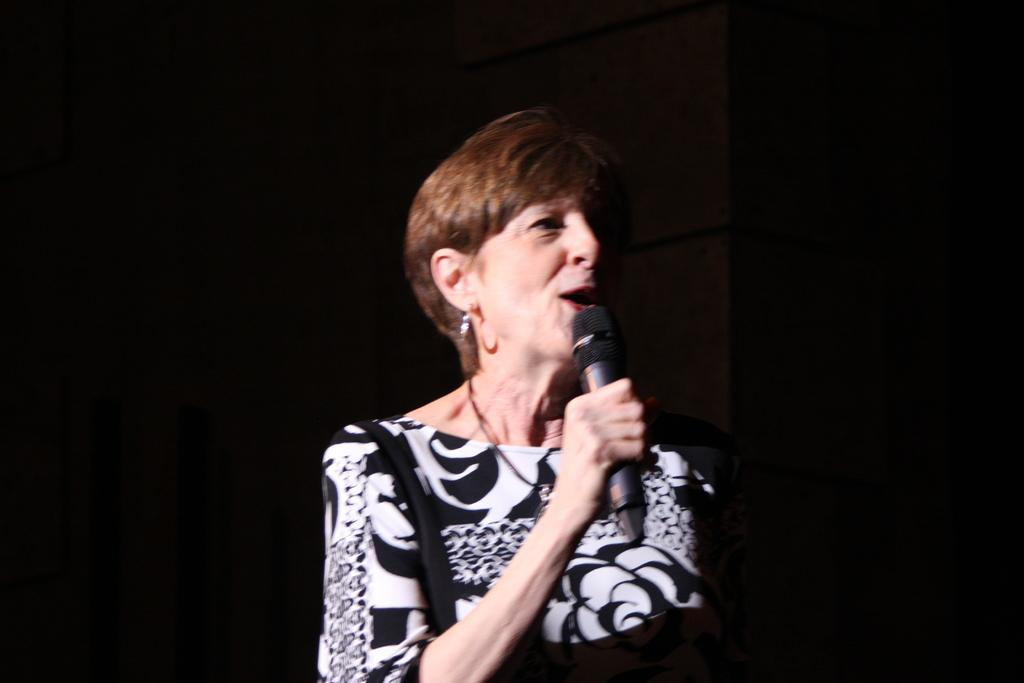Who is the main subject in the image? There is a woman in the image. What is the woman wearing? The woman is wearing a black dress. What is the woman holding in the image? The woman is holding a microphone. What is the woman doing with her mouth? The woman's mouth is open. How would you describe the background of the image? The background of the image has a dark view. Can you see any bananas in the image? No, there are no bananas present in the image. What type of property does the woman own in the image? There is no information about the woman owning any property in the image. 